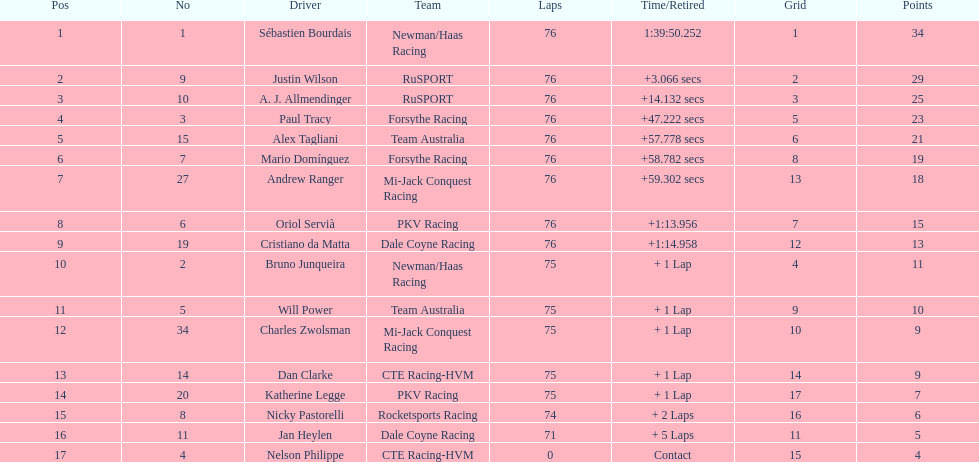Who is the driver with the most points earned? Sebastien Bourdais. 